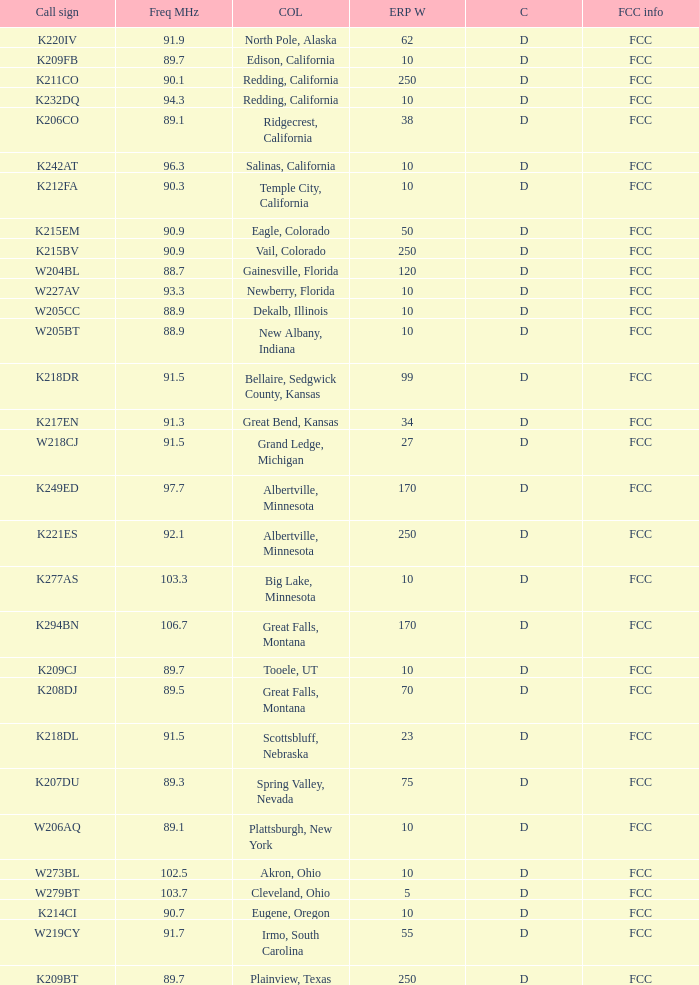What is the FCC info of the translator with an Irmo, South Carolina city license? FCC. 